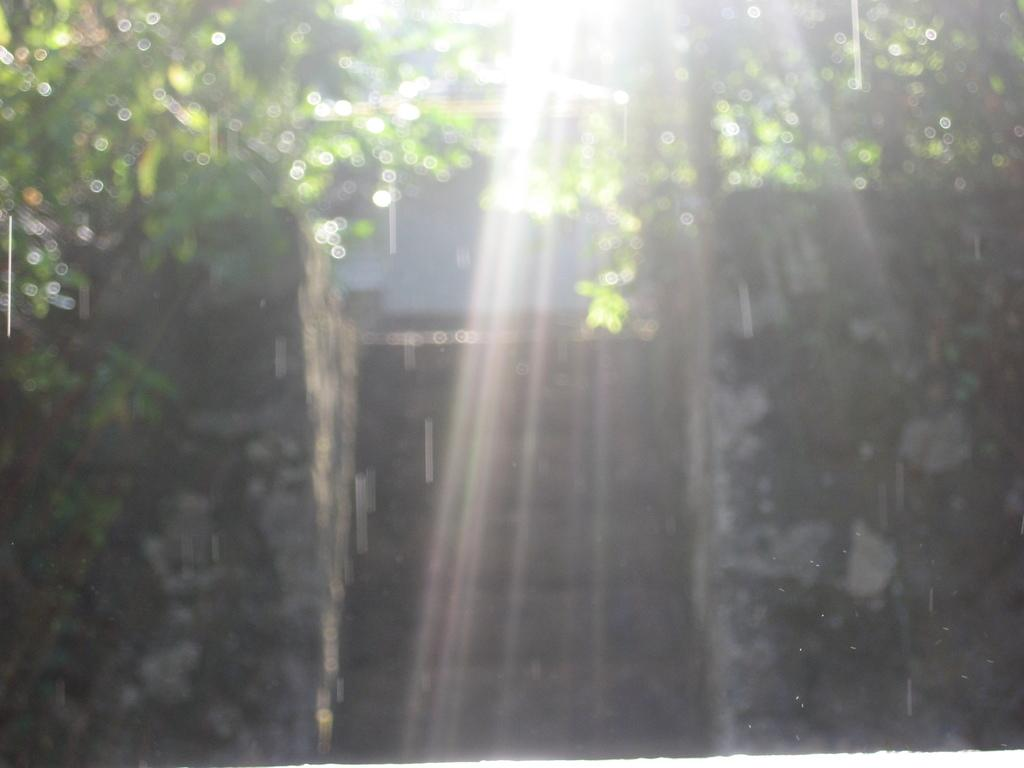What type of structure is present in the image? There is a door in the image. What surrounds the door in the image? There are walls in the image. What natural elements can be seen in the image? Leaves are visible in the image. What type of bread can be seen being exchanged through the door in the image? There is no bread or exchange happening in the image; it only features a door, walls, and leaves. 